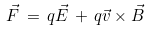Convert formula to latex. <formula><loc_0><loc_0><loc_500><loc_500>\vec { F } \, = \, q \vec { E } \, + \, q \vec { v } \times \vec { B }</formula> 